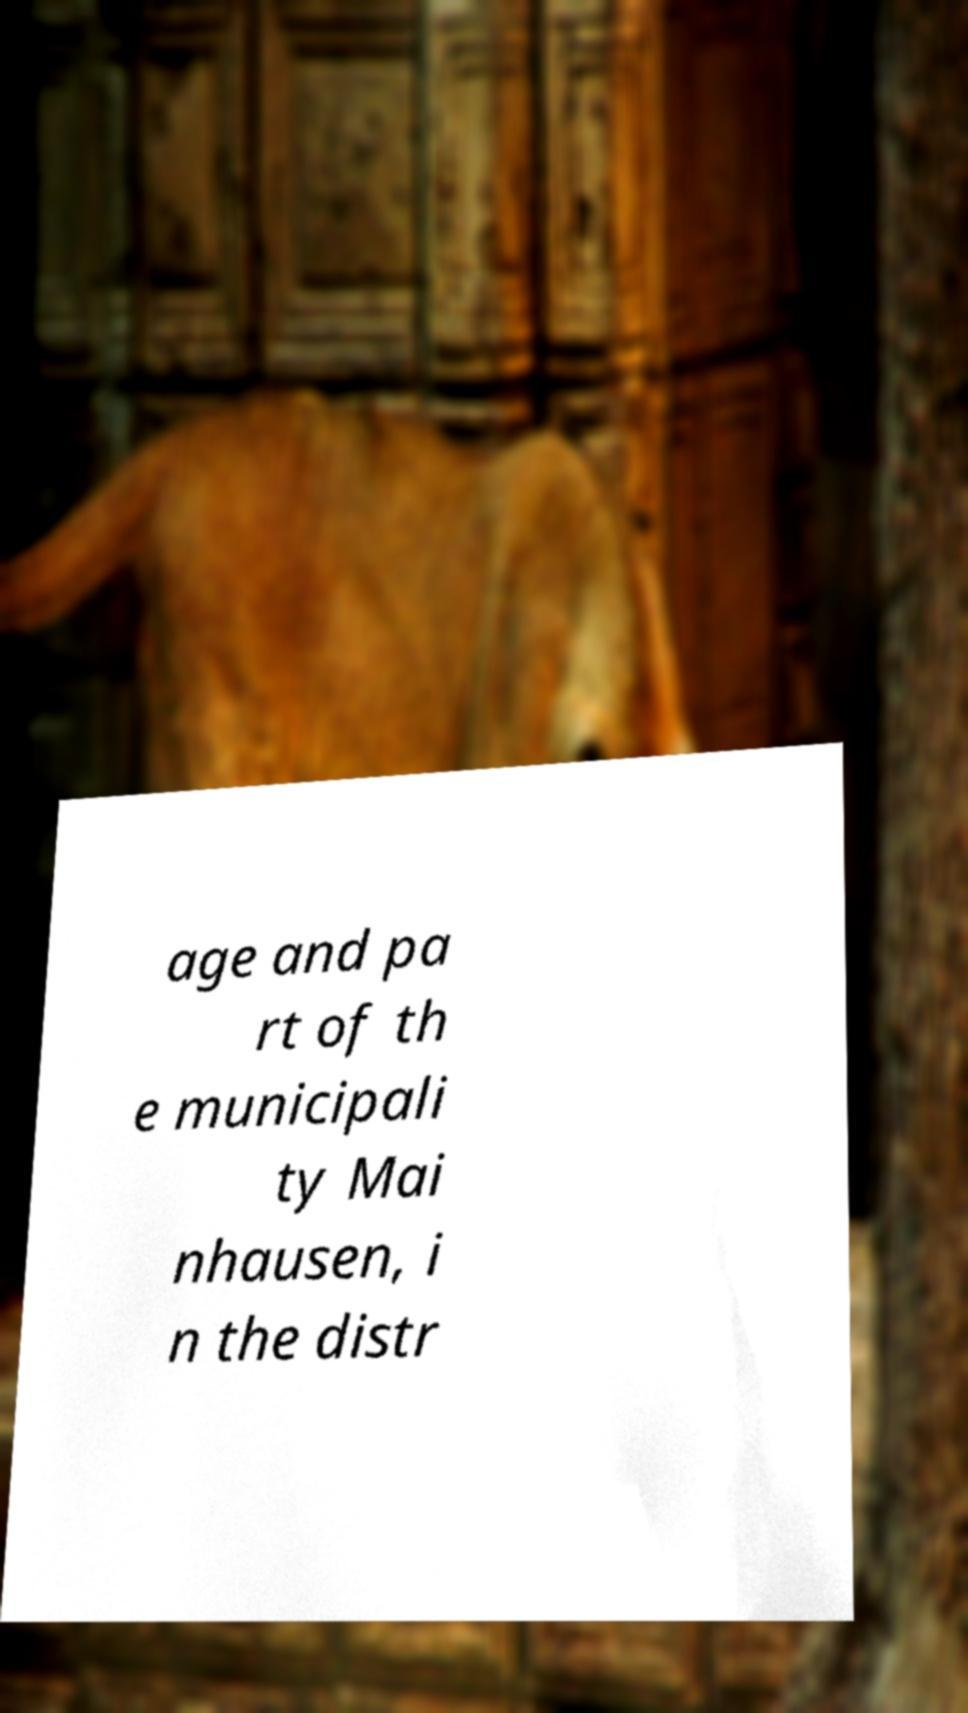What messages or text are displayed in this image? I need them in a readable, typed format. age and pa rt of th e municipali ty Mai nhausen, i n the distr 